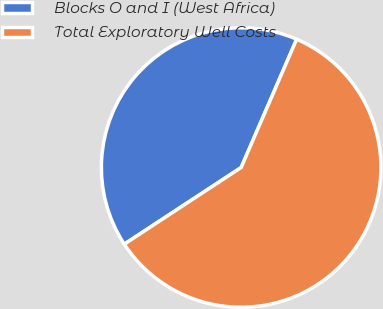Convert chart. <chart><loc_0><loc_0><loc_500><loc_500><pie_chart><fcel>Blocks O and I (West Africa)<fcel>Total Exploratory Well Costs<nl><fcel>40.74%<fcel>59.26%<nl></chart> 